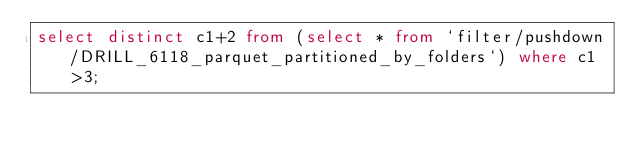<code> <loc_0><loc_0><loc_500><loc_500><_SQL_>select distinct c1+2 from (select * from `filter/pushdown/DRILL_6118_parquet_partitioned_by_folders`) where c1>3;</code> 